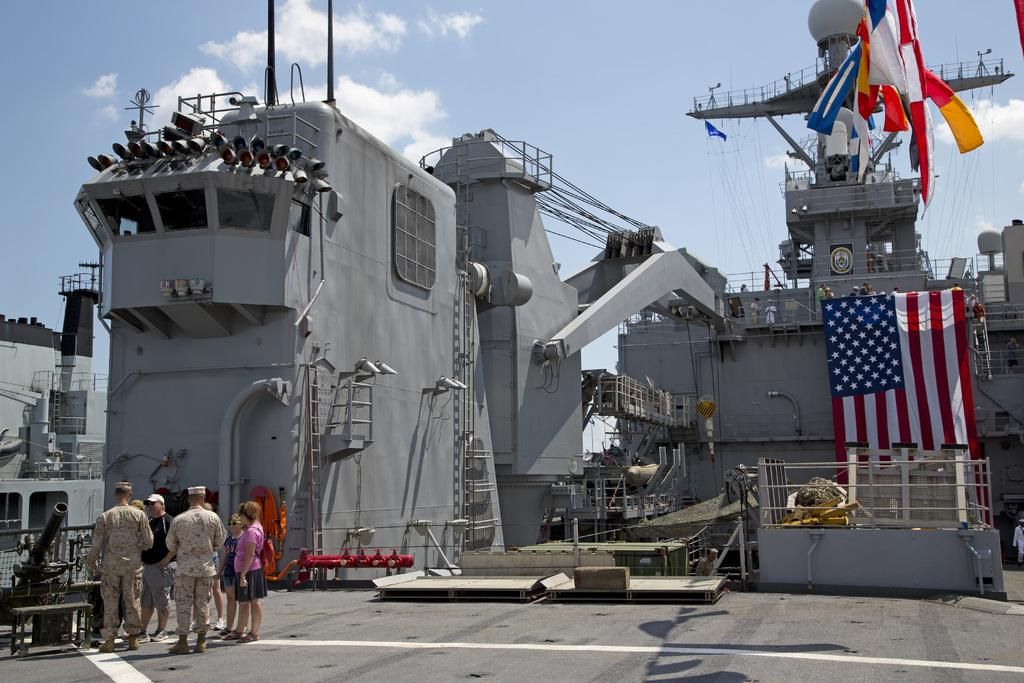What is the main subject of the image? The main subject of the image is a ship. Are there any additional features on the ship? Yes, there are flags, persons standing on the surface, electric lights, grills, and poles present on the ship. What can be seen in the background of the image? The sky is visible in the background of the image, and there are clouds present in the sky. Can you tell me how many units are visible on the bridge in the image? There is no bridge present in the image, and therefore no units can be observed. 